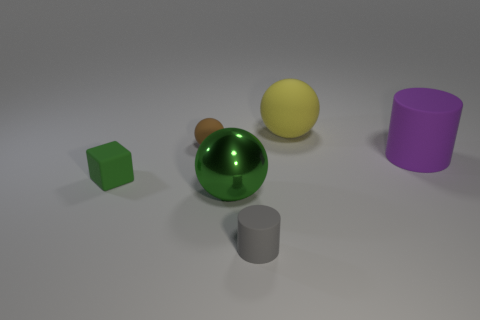Is there a big purple cylinder that has the same material as the brown object?
Offer a very short reply. Yes. There is a matte sphere that is to the right of the sphere that is in front of the purple rubber object; is there a thing behind it?
Offer a very short reply. No. What shape is the gray rubber object that is the same size as the block?
Your answer should be very brief. Cylinder. There is a green thing right of the small green matte block; is it the same size as the rubber sphere on the right side of the tiny brown thing?
Provide a short and direct response. Yes. What number of tiny brown matte balls are there?
Keep it short and to the point. 1. What size is the matte thing behind the rubber sphere that is on the left side of the ball that is to the right of the gray cylinder?
Offer a terse response. Large. Is the color of the metallic object the same as the rubber cube?
Your answer should be very brief. Yes. There is a big yellow rubber sphere; what number of large green shiny balls are left of it?
Your response must be concise. 1. Are there an equal number of small rubber spheres in front of the big matte cylinder and large objects?
Give a very brief answer. No. How many objects are either brown spheres or big purple matte cylinders?
Make the answer very short. 2. 